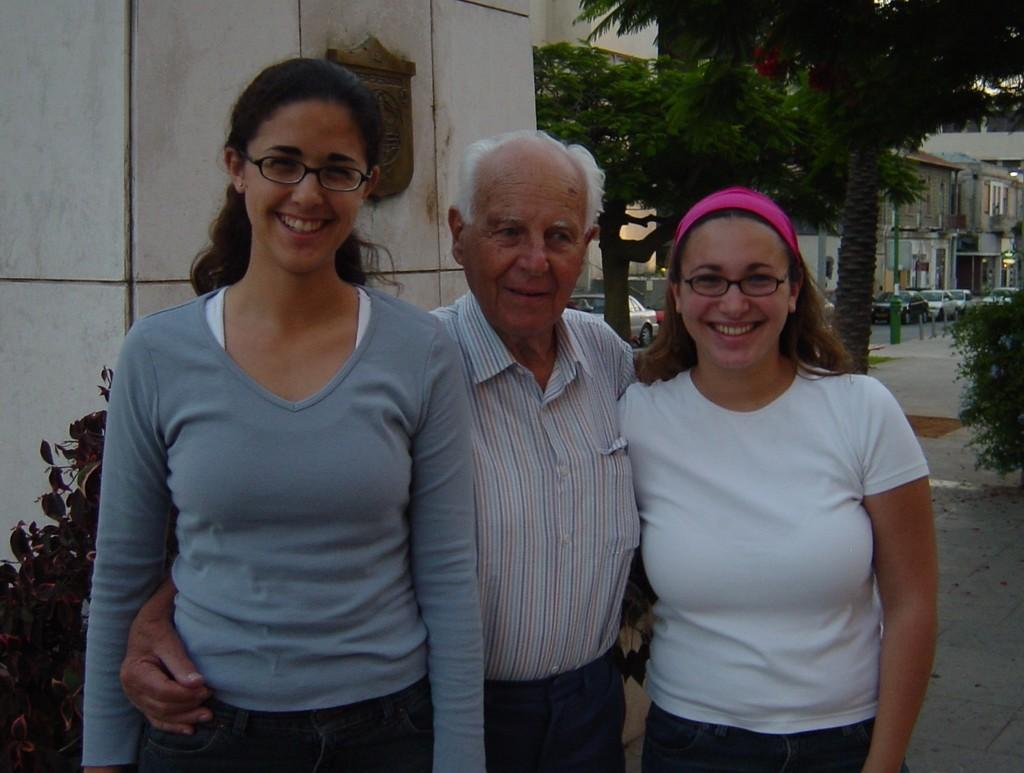How many people are in the image? There are three individuals in the image, two women and an old man. What is the facial expression of the people in the image? All three individuals are smiling in the image. What can be seen in the background of the image? There are trees and a building in the background of the image. What type of breakfast is being served on the sheet in the image? There is no sheet or breakfast present in the image. 